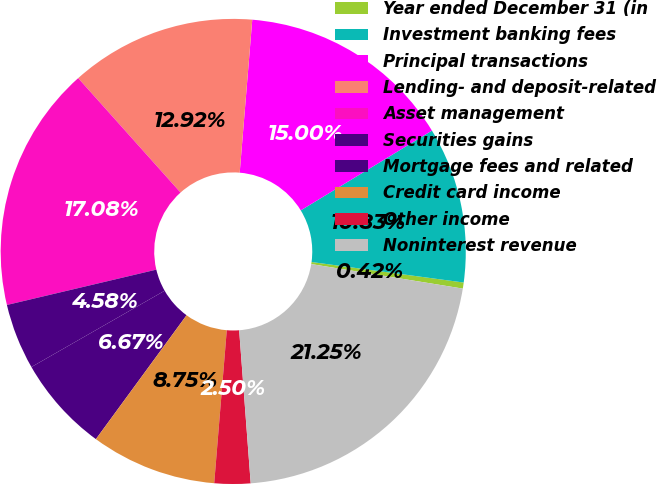Convert chart to OTSL. <chart><loc_0><loc_0><loc_500><loc_500><pie_chart><fcel>Year ended December 31 (in<fcel>Investment banking fees<fcel>Principal transactions<fcel>Lending- and deposit-related<fcel>Asset management<fcel>Securities gains<fcel>Mortgage fees and related<fcel>Credit card income<fcel>Other income<fcel>Noninterest revenue<nl><fcel>0.42%<fcel>10.83%<fcel>15.0%<fcel>12.92%<fcel>17.08%<fcel>4.58%<fcel>6.67%<fcel>8.75%<fcel>2.5%<fcel>21.25%<nl></chart> 